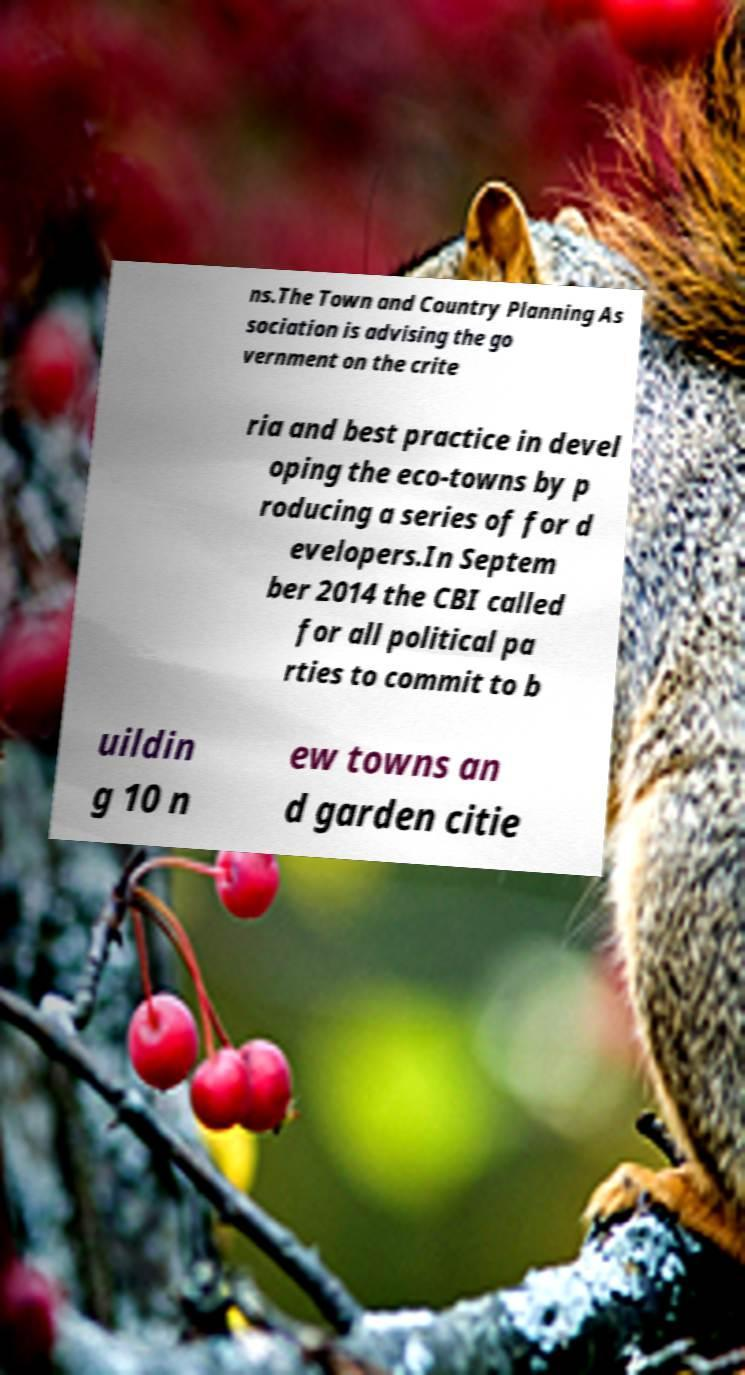Could you extract and type out the text from this image? ns.The Town and Country Planning As sociation is advising the go vernment on the crite ria and best practice in devel oping the eco-towns by p roducing a series of for d evelopers.In Septem ber 2014 the CBI called for all political pa rties to commit to b uildin g 10 n ew towns an d garden citie 